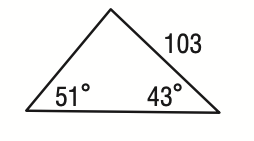Answer the mathemtical geometry problem and directly provide the correct option letter.
Question: What is the perimeter of the triangle shown below? Round to the nearest tenth.
Choices: A: 222.6 B: 300.6 C: 325.6 D: 377.6 C 